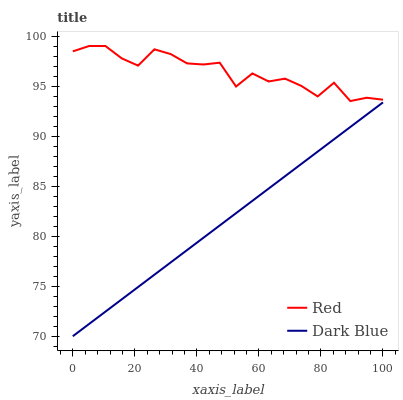Does Dark Blue have the minimum area under the curve?
Answer yes or no. Yes. Does Red have the maximum area under the curve?
Answer yes or no. Yes. Does Red have the minimum area under the curve?
Answer yes or no. No. Is Dark Blue the smoothest?
Answer yes or no. Yes. Is Red the roughest?
Answer yes or no. Yes. Is Red the smoothest?
Answer yes or no. No. Does Dark Blue have the lowest value?
Answer yes or no. Yes. Does Red have the lowest value?
Answer yes or no. No. Does Red have the highest value?
Answer yes or no. Yes. Is Dark Blue less than Red?
Answer yes or no. Yes. Is Red greater than Dark Blue?
Answer yes or no. Yes. Does Dark Blue intersect Red?
Answer yes or no. No. 